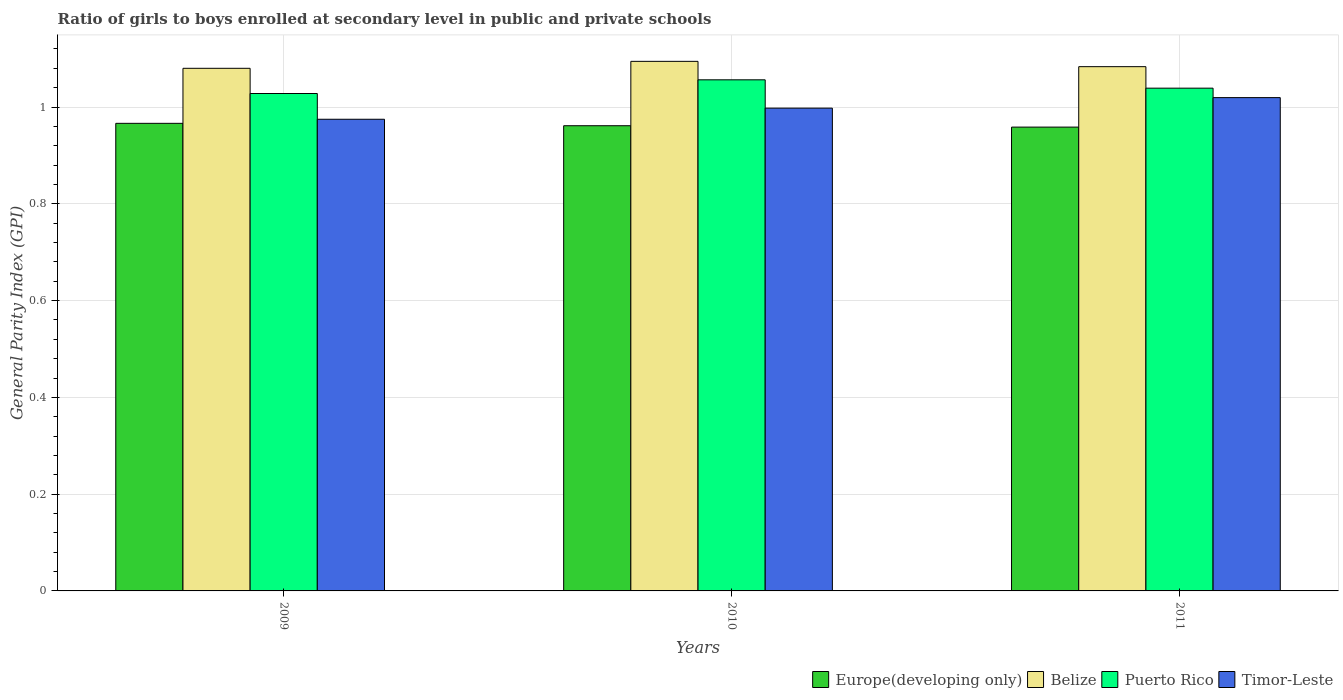How many different coloured bars are there?
Your answer should be very brief. 4. How many bars are there on the 1st tick from the right?
Your response must be concise. 4. What is the label of the 1st group of bars from the left?
Provide a short and direct response. 2009. In how many cases, is the number of bars for a given year not equal to the number of legend labels?
Your response must be concise. 0. What is the general parity index in Timor-Leste in 2011?
Offer a terse response. 1.02. Across all years, what is the maximum general parity index in Timor-Leste?
Provide a short and direct response. 1.02. Across all years, what is the minimum general parity index in Belize?
Offer a very short reply. 1.08. In which year was the general parity index in Europe(developing only) maximum?
Offer a terse response. 2009. In which year was the general parity index in Timor-Leste minimum?
Offer a terse response. 2009. What is the total general parity index in Europe(developing only) in the graph?
Provide a succinct answer. 2.89. What is the difference between the general parity index in Puerto Rico in 2009 and that in 2010?
Offer a very short reply. -0.03. What is the difference between the general parity index in Puerto Rico in 2011 and the general parity index in Timor-Leste in 2010?
Your answer should be compact. 0.04. What is the average general parity index in Europe(developing only) per year?
Offer a very short reply. 0.96. In the year 2010, what is the difference between the general parity index in Timor-Leste and general parity index in Belize?
Your answer should be very brief. -0.1. In how many years, is the general parity index in Puerto Rico greater than 0.44?
Give a very brief answer. 3. What is the ratio of the general parity index in Belize in 2009 to that in 2011?
Ensure brevity in your answer.  1. Is the general parity index in Timor-Leste in 2009 less than that in 2011?
Keep it short and to the point. Yes. Is the difference between the general parity index in Timor-Leste in 2010 and 2011 greater than the difference between the general parity index in Belize in 2010 and 2011?
Provide a short and direct response. No. What is the difference between the highest and the second highest general parity index in Timor-Leste?
Provide a succinct answer. 0.02. What is the difference between the highest and the lowest general parity index in Timor-Leste?
Your response must be concise. 0.04. In how many years, is the general parity index in Europe(developing only) greater than the average general parity index in Europe(developing only) taken over all years?
Your answer should be compact. 1. What does the 4th bar from the left in 2011 represents?
Offer a very short reply. Timor-Leste. What does the 4th bar from the right in 2009 represents?
Provide a succinct answer. Europe(developing only). How many bars are there?
Provide a short and direct response. 12. What is the difference between two consecutive major ticks on the Y-axis?
Make the answer very short. 0.2. Are the values on the major ticks of Y-axis written in scientific E-notation?
Offer a terse response. No. Does the graph contain any zero values?
Your answer should be compact. No. Does the graph contain grids?
Provide a short and direct response. Yes. How are the legend labels stacked?
Give a very brief answer. Horizontal. What is the title of the graph?
Provide a succinct answer. Ratio of girls to boys enrolled at secondary level in public and private schools. What is the label or title of the Y-axis?
Ensure brevity in your answer.  General Parity Index (GPI). What is the General Parity Index (GPI) of Europe(developing only) in 2009?
Offer a terse response. 0.97. What is the General Parity Index (GPI) in Belize in 2009?
Offer a terse response. 1.08. What is the General Parity Index (GPI) of Puerto Rico in 2009?
Make the answer very short. 1.03. What is the General Parity Index (GPI) in Timor-Leste in 2009?
Keep it short and to the point. 0.97. What is the General Parity Index (GPI) of Europe(developing only) in 2010?
Your answer should be compact. 0.96. What is the General Parity Index (GPI) in Belize in 2010?
Your answer should be very brief. 1.09. What is the General Parity Index (GPI) in Puerto Rico in 2010?
Your answer should be very brief. 1.06. What is the General Parity Index (GPI) of Timor-Leste in 2010?
Offer a terse response. 1. What is the General Parity Index (GPI) in Europe(developing only) in 2011?
Your answer should be compact. 0.96. What is the General Parity Index (GPI) in Belize in 2011?
Offer a very short reply. 1.08. What is the General Parity Index (GPI) in Puerto Rico in 2011?
Your response must be concise. 1.04. What is the General Parity Index (GPI) in Timor-Leste in 2011?
Keep it short and to the point. 1.02. Across all years, what is the maximum General Parity Index (GPI) of Europe(developing only)?
Offer a terse response. 0.97. Across all years, what is the maximum General Parity Index (GPI) of Belize?
Offer a terse response. 1.09. Across all years, what is the maximum General Parity Index (GPI) in Puerto Rico?
Offer a terse response. 1.06. Across all years, what is the maximum General Parity Index (GPI) in Timor-Leste?
Provide a short and direct response. 1.02. Across all years, what is the minimum General Parity Index (GPI) of Europe(developing only)?
Provide a short and direct response. 0.96. Across all years, what is the minimum General Parity Index (GPI) in Belize?
Offer a very short reply. 1.08. Across all years, what is the minimum General Parity Index (GPI) of Puerto Rico?
Offer a very short reply. 1.03. Across all years, what is the minimum General Parity Index (GPI) of Timor-Leste?
Your answer should be very brief. 0.97. What is the total General Parity Index (GPI) of Europe(developing only) in the graph?
Your answer should be compact. 2.89. What is the total General Parity Index (GPI) of Belize in the graph?
Make the answer very short. 3.26. What is the total General Parity Index (GPI) of Puerto Rico in the graph?
Offer a terse response. 3.12. What is the total General Parity Index (GPI) of Timor-Leste in the graph?
Keep it short and to the point. 2.99. What is the difference between the General Parity Index (GPI) in Europe(developing only) in 2009 and that in 2010?
Ensure brevity in your answer.  0. What is the difference between the General Parity Index (GPI) of Belize in 2009 and that in 2010?
Provide a short and direct response. -0.01. What is the difference between the General Parity Index (GPI) in Puerto Rico in 2009 and that in 2010?
Keep it short and to the point. -0.03. What is the difference between the General Parity Index (GPI) in Timor-Leste in 2009 and that in 2010?
Your answer should be very brief. -0.02. What is the difference between the General Parity Index (GPI) in Europe(developing only) in 2009 and that in 2011?
Give a very brief answer. 0.01. What is the difference between the General Parity Index (GPI) of Belize in 2009 and that in 2011?
Ensure brevity in your answer.  -0. What is the difference between the General Parity Index (GPI) of Puerto Rico in 2009 and that in 2011?
Your answer should be compact. -0.01. What is the difference between the General Parity Index (GPI) of Timor-Leste in 2009 and that in 2011?
Your answer should be compact. -0.04. What is the difference between the General Parity Index (GPI) in Europe(developing only) in 2010 and that in 2011?
Your answer should be very brief. 0. What is the difference between the General Parity Index (GPI) of Belize in 2010 and that in 2011?
Your response must be concise. 0.01. What is the difference between the General Parity Index (GPI) of Puerto Rico in 2010 and that in 2011?
Provide a succinct answer. 0.02. What is the difference between the General Parity Index (GPI) of Timor-Leste in 2010 and that in 2011?
Give a very brief answer. -0.02. What is the difference between the General Parity Index (GPI) of Europe(developing only) in 2009 and the General Parity Index (GPI) of Belize in 2010?
Your response must be concise. -0.13. What is the difference between the General Parity Index (GPI) of Europe(developing only) in 2009 and the General Parity Index (GPI) of Puerto Rico in 2010?
Provide a succinct answer. -0.09. What is the difference between the General Parity Index (GPI) in Europe(developing only) in 2009 and the General Parity Index (GPI) in Timor-Leste in 2010?
Make the answer very short. -0.03. What is the difference between the General Parity Index (GPI) in Belize in 2009 and the General Parity Index (GPI) in Puerto Rico in 2010?
Keep it short and to the point. 0.02. What is the difference between the General Parity Index (GPI) in Belize in 2009 and the General Parity Index (GPI) in Timor-Leste in 2010?
Make the answer very short. 0.08. What is the difference between the General Parity Index (GPI) in Puerto Rico in 2009 and the General Parity Index (GPI) in Timor-Leste in 2010?
Provide a short and direct response. 0.03. What is the difference between the General Parity Index (GPI) of Europe(developing only) in 2009 and the General Parity Index (GPI) of Belize in 2011?
Offer a very short reply. -0.12. What is the difference between the General Parity Index (GPI) of Europe(developing only) in 2009 and the General Parity Index (GPI) of Puerto Rico in 2011?
Provide a short and direct response. -0.07. What is the difference between the General Parity Index (GPI) in Europe(developing only) in 2009 and the General Parity Index (GPI) in Timor-Leste in 2011?
Offer a very short reply. -0.05. What is the difference between the General Parity Index (GPI) in Belize in 2009 and the General Parity Index (GPI) in Puerto Rico in 2011?
Provide a short and direct response. 0.04. What is the difference between the General Parity Index (GPI) of Belize in 2009 and the General Parity Index (GPI) of Timor-Leste in 2011?
Provide a succinct answer. 0.06. What is the difference between the General Parity Index (GPI) of Puerto Rico in 2009 and the General Parity Index (GPI) of Timor-Leste in 2011?
Offer a terse response. 0.01. What is the difference between the General Parity Index (GPI) of Europe(developing only) in 2010 and the General Parity Index (GPI) of Belize in 2011?
Make the answer very short. -0.12. What is the difference between the General Parity Index (GPI) of Europe(developing only) in 2010 and the General Parity Index (GPI) of Puerto Rico in 2011?
Offer a terse response. -0.08. What is the difference between the General Parity Index (GPI) of Europe(developing only) in 2010 and the General Parity Index (GPI) of Timor-Leste in 2011?
Keep it short and to the point. -0.06. What is the difference between the General Parity Index (GPI) in Belize in 2010 and the General Parity Index (GPI) in Puerto Rico in 2011?
Provide a short and direct response. 0.06. What is the difference between the General Parity Index (GPI) in Belize in 2010 and the General Parity Index (GPI) in Timor-Leste in 2011?
Your response must be concise. 0.07. What is the difference between the General Parity Index (GPI) of Puerto Rico in 2010 and the General Parity Index (GPI) of Timor-Leste in 2011?
Ensure brevity in your answer.  0.04. What is the average General Parity Index (GPI) of Europe(developing only) per year?
Give a very brief answer. 0.96. What is the average General Parity Index (GPI) of Belize per year?
Your response must be concise. 1.09. What is the average General Parity Index (GPI) of Puerto Rico per year?
Offer a terse response. 1.04. In the year 2009, what is the difference between the General Parity Index (GPI) in Europe(developing only) and General Parity Index (GPI) in Belize?
Your response must be concise. -0.11. In the year 2009, what is the difference between the General Parity Index (GPI) of Europe(developing only) and General Parity Index (GPI) of Puerto Rico?
Give a very brief answer. -0.06. In the year 2009, what is the difference between the General Parity Index (GPI) in Europe(developing only) and General Parity Index (GPI) in Timor-Leste?
Your response must be concise. -0.01. In the year 2009, what is the difference between the General Parity Index (GPI) in Belize and General Parity Index (GPI) in Puerto Rico?
Your answer should be very brief. 0.05. In the year 2009, what is the difference between the General Parity Index (GPI) of Belize and General Parity Index (GPI) of Timor-Leste?
Offer a terse response. 0.11. In the year 2009, what is the difference between the General Parity Index (GPI) of Puerto Rico and General Parity Index (GPI) of Timor-Leste?
Your answer should be very brief. 0.05. In the year 2010, what is the difference between the General Parity Index (GPI) of Europe(developing only) and General Parity Index (GPI) of Belize?
Provide a succinct answer. -0.13. In the year 2010, what is the difference between the General Parity Index (GPI) in Europe(developing only) and General Parity Index (GPI) in Puerto Rico?
Provide a short and direct response. -0.09. In the year 2010, what is the difference between the General Parity Index (GPI) of Europe(developing only) and General Parity Index (GPI) of Timor-Leste?
Ensure brevity in your answer.  -0.04. In the year 2010, what is the difference between the General Parity Index (GPI) in Belize and General Parity Index (GPI) in Puerto Rico?
Your answer should be very brief. 0.04. In the year 2010, what is the difference between the General Parity Index (GPI) of Belize and General Parity Index (GPI) of Timor-Leste?
Your response must be concise. 0.1. In the year 2010, what is the difference between the General Parity Index (GPI) of Puerto Rico and General Parity Index (GPI) of Timor-Leste?
Offer a terse response. 0.06. In the year 2011, what is the difference between the General Parity Index (GPI) in Europe(developing only) and General Parity Index (GPI) in Belize?
Your answer should be very brief. -0.12. In the year 2011, what is the difference between the General Parity Index (GPI) in Europe(developing only) and General Parity Index (GPI) in Puerto Rico?
Give a very brief answer. -0.08. In the year 2011, what is the difference between the General Parity Index (GPI) of Europe(developing only) and General Parity Index (GPI) of Timor-Leste?
Provide a short and direct response. -0.06. In the year 2011, what is the difference between the General Parity Index (GPI) of Belize and General Parity Index (GPI) of Puerto Rico?
Provide a short and direct response. 0.04. In the year 2011, what is the difference between the General Parity Index (GPI) of Belize and General Parity Index (GPI) of Timor-Leste?
Offer a very short reply. 0.06. In the year 2011, what is the difference between the General Parity Index (GPI) in Puerto Rico and General Parity Index (GPI) in Timor-Leste?
Give a very brief answer. 0.02. What is the ratio of the General Parity Index (GPI) of Europe(developing only) in 2009 to that in 2010?
Provide a short and direct response. 1.01. What is the ratio of the General Parity Index (GPI) in Belize in 2009 to that in 2010?
Your response must be concise. 0.99. What is the ratio of the General Parity Index (GPI) in Puerto Rico in 2009 to that in 2010?
Keep it short and to the point. 0.97. What is the ratio of the General Parity Index (GPI) in Timor-Leste in 2009 to that in 2010?
Offer a very short reply. 0.98. What is the ratio of the General Parity Index (GPI) in Belize in 2009 to that in 2011?
Your answer should be very brief. 1. What is the ratio of the General Parity Index (GPI) in Puerto Rico in 2009 to that in 2011?
Give a very brief answer. 0.99. What is the ratio of the General Parity Index (GPI) of Timor-Leste in 2009 to that in 2011?
Ensure brevity in your answer.  0.96. What is the ratio of the General Parity Index (GPI) of Puerto Rico in 2010 to that in 2011?
Provide a short and direct response. 1.02. What is the ratio of the General Parity Index (GPI) in Timor-Leste in 2010 to that in 2011?
Your response must be concise. 0.98. What is the difference between the highest and the second highest General Parity Index (GPI) in Europe(developing only)?
Keep it short and to the point. 0. What is the difference between the highest and the second highest General Parity Index (GPI) of Belize?
Your answer should be very brief. 0.01. What is the difference between the highest and the second highest General Parity Index (GPI) in Puerto Rico?
Your answer should be compact. 0.02. What is the difference between the highest and the second highest General Parity Index (GPI) of Timor-Leste?
Offer a terse response. 0.02. What is the difference between the highest and the lowest General Parity Index (GPI) in Europe(developing only)?
Offer a very short reply. 0.01. What is the difference between the highest and the lowest General Parity Index (GPI) in Belize?
Your answer should be very brief. 0.01. What is the difference between the highest and the lowest General Parity Index (GPI) of Puerto Rico?
Provide a short and direct response. 0.03. What is the difference between the highest and the lowest General Parity Index (GPI) of Timor-Leste?
Offer a terse response. 0.04. 